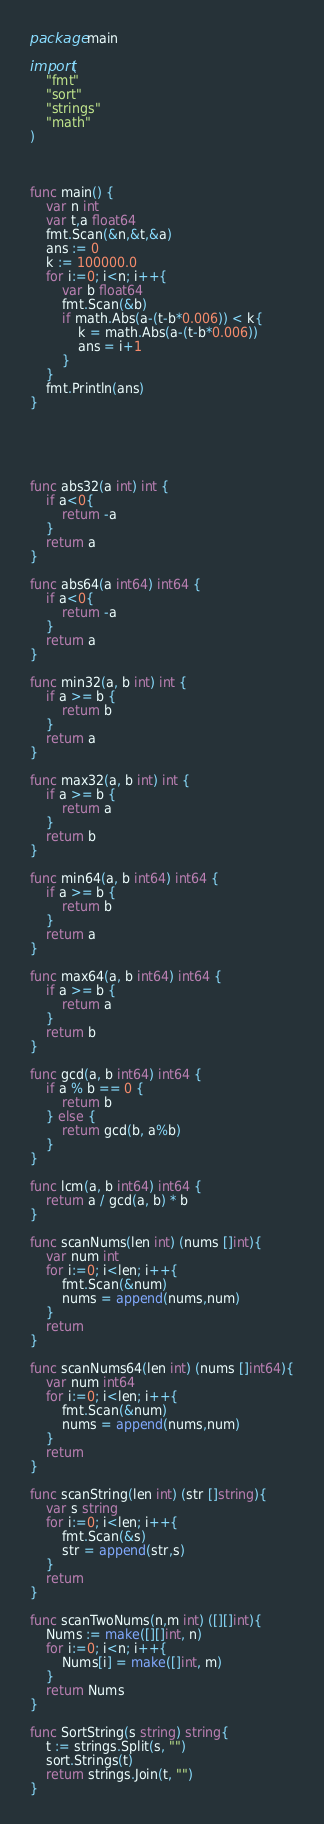Convert code to text. <code><loc_0><loc_0><loc_500><loc_500><_Go_>package main

import(
    "fmt"
    "sort"
    "strings"
    "math"
)



func main() {
    var n int
    var t,a float64
    fmt.Scan(&n,&t,&a)
    ans := 0
    k := 100000.0
    for i:=0; i<n; i++{
        var b float64
        fmt.Scan(&b)
        if math.Abs(a-(t-b*0.006)) < k{
            k = math.Abs(a-(t-b*0.006))
            ans = i+1
        }
    }
    fmt.Println(ans)
}





func abs32(a int) int {
    if a<0{
        return -a
    }
    return a
}

func abs64(a int64) int64 {
    if a<0{
        return -a
    }
    return a
}

func min32(a, b int) int {
    if a >= b {
        return b
    }
    return a
}

func max32(a, b int) int {
    if a >= b {
        return a
    }
    return b
}

func min64(a, b int64) int64 {
    if a >= b {
        return b
    }
    return a
}

func max64(a, b int64) int64 {
    if a >= b {
        return a
    }
    return b
}

func gcd(a, b int64) int64 {
    if a % b == 0 {
        return b
    } else {
        return gcd(b, a%b)
    }
}

func lcm(a, b int64) int64 {
    return a / gcd(a, b) * b
}

func scanNums(len int) (nums []int){
    var num int
    for i:=0; i<len; i++{
        fmt.Scan(&num)
        nums = append(nums,num)
    }
    return
}

func scanNums64(len int) (nums []int64){
    var num int64
    for i:=0; i<len; i++{
        fmt.Scan(&num)
        nums = append(nums,num)
    }
    return
}

func scanString(len int) (str []string){
    var s string
    for i:=0; i<len; i++{
        fmt.Scan(&s)
        str = append(str,s)
    }
    return
}

func scanTwoNums(n,m int) ([][]int){
    Nums := make([][]int, n)
    for i:=0; i<n; i++{
        Nums[i] = make([]int, m)
    }
    return Nums
}

func SortString(s string) string{
    t := strings.Split(s, "")
    sort.Strings(t)
    return strings.Join(t, "")
}
</code> 